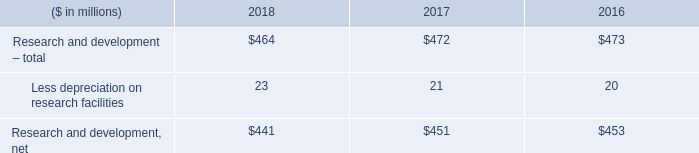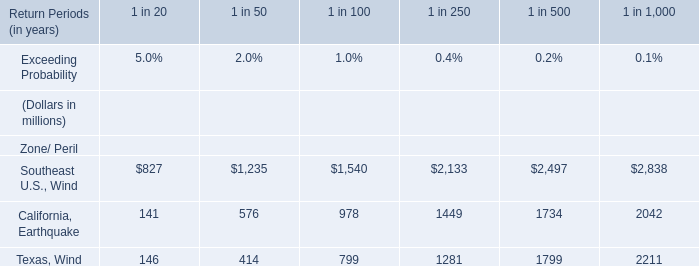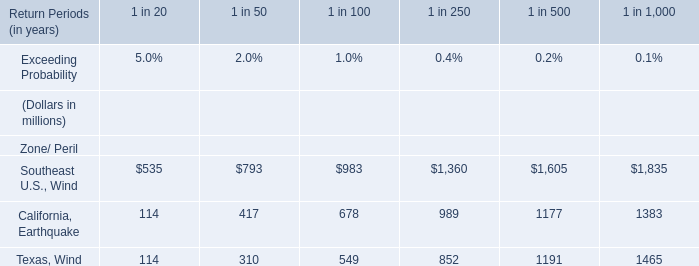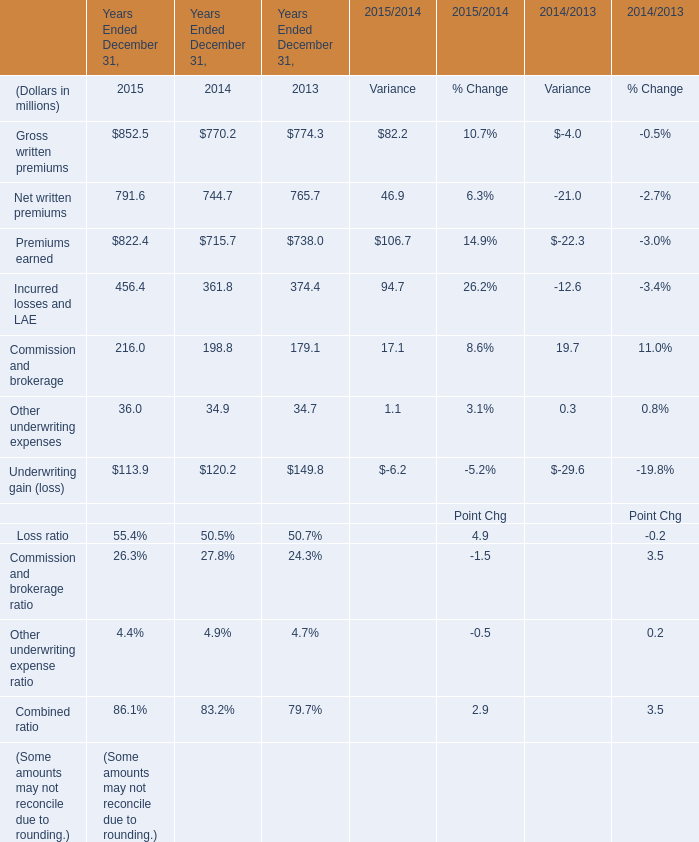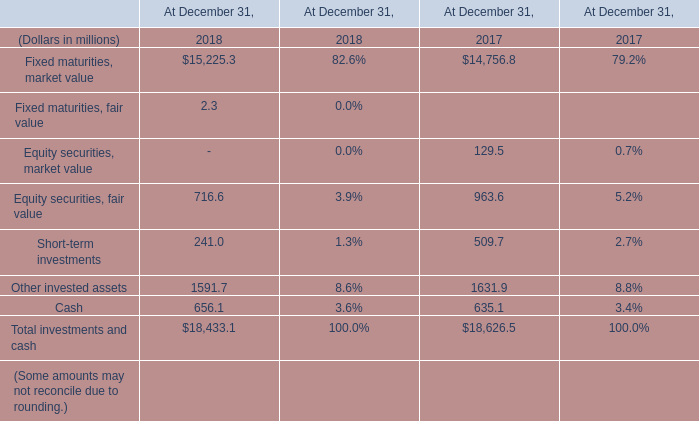What is the sum of California, Earthquake for 1 in 1,000 in Table 1 and Southeast U.S., Wind for 1 in 250 in Table 2? (in million) 
Computations: (2042 + 1360)
Answer: 3402.0. 